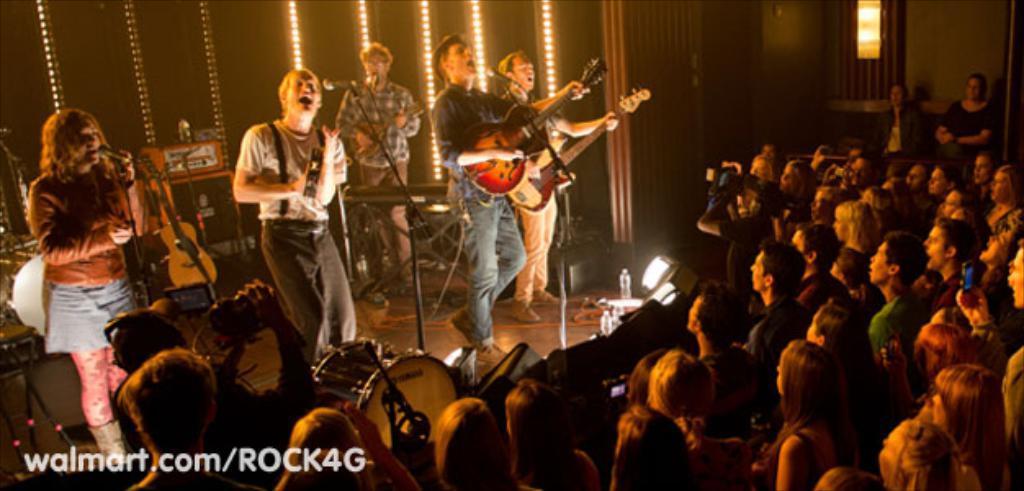In one or two sentences, can you explain what this image depicts? In this image I can see there are group of people who are singing and playing guitar in front of the microphone and on the right side we have a group of people who are standing. 